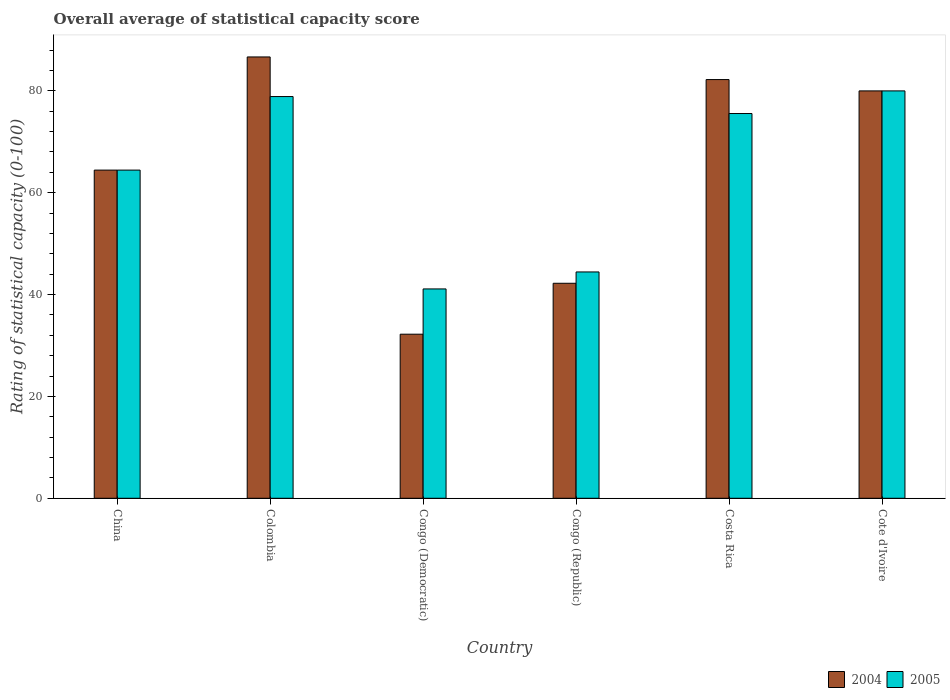How many different coloured bars are there?
Your response must be concise. 2. How many groups of bars are there?
Offer a very short reply. 6. Are the number of bars per tick equal to the number of legend labels?
Provide a succinct answer. Yes. How many bars are there on the 3rd tick from the right?
Provide a short and direct response. 2. In how many cases, is the number of bars for a given country not equal to the number of legend labels?
Offer a very short reply. 0. What is the rating of statistical capacity in 2005 in Costa Rica?
Your answer should be compact. 75.56. Across all countries, what is the maximum rating of statistical capacity in 2005?
Offer a very short reply. 80. Across all countries, what is the minimum rating of statistical capacity in 2004?
Your answer should be compact. 32.22. In which country was the rating of statistical capacity in 2005 maximum?
Give a very brief answer. Cote d'Ivoire. In which country was the rating of statistical capacity in 2005 minimum?
Offer a very short reply. Congo (Democratic). What is the total rating of statistical capacity in 2005 in the graph?
Offer a terse response. 384.44. What is the difference between the rating of statistical capacity in 2004 in Congo (Democratic) and that in Cote d'Ivoire?
Make the answer very short. -47.78. What is the difference between the rating of statistical capacity in 2005 in Congo (Democratic) and the rating of statistical capacity in 2004 in Cote d'Ivoire?
Offer a terse response. -38.89. What is the average rating of statistical capacity in 2005 per country?
Offer a very short reply. 64.07. What is the difference between the rating of statistical capacity of/in 2005 and rating of statistical capacity of/in 2004 in Congo (Democratic)?
Keep it short and to the point. 8.89. In how many countries, is the rating of statistical capacity in 2004 greater than 44?
Provide a short and direct response. 4. What is the ratio of the rating of statistical capacity in 2004 in Colombia to that in Congo (Republic)?
Your answer should be very brief. 2.05. Is the rating of statistical capacity in 2004 in China less than that in Costa Rica?
Ensure brevity in your answer.  Yes. What is the difference between the highest and the second highest rating of statistical capacity in 2004?
Ensure brevity in your answer.  -2.22. What is the difference between the highest and the lowest rating of statistical capacity in 2005?
Keep it short and to the point. 38.89. Is the sum of the rating of statistical capacity in 2004 in Congo (Democratic) and Congo (Republic) greater than the maximum rating of statistical capacity in 2005 across all countries?
Your response must be concise. No. How many bars are there?
Provide a short and direct response. 12. How many countries are there in the graph?
Your answer should be very brief. 6. What is the difference between two consecutive major ticks on the Y-axis?
Offer a very short reply. 20. Are the values on the major ticks of Y-axis written in scientific E-notation?
Your answer should be very brief. No. Does the graph contain any zero values?
Provide a succinct answer. No. Where does the legend appear in the graph?
Provide a short and direct response. Bottom right. How many legend labels are there?
Your answer should be very brief. 2. What is the title of the graph?
Your response must be concise. Overall average of statistical capacity score. Does "1973" appear as one of the legend labels in the graph?
Your response must be concise. No. What is the label or title of the X-axis?
Make the answer very short. Country. What is the label or title of the Y-axis?
Provide a succinct answer. Rating of statistical capacity (0-100). What is the Rating of statistical capacity (0-100) in 2004 in China?
Ensure brevity in your answer.  64.44. What is the Rating of statistical capacity (0-100) in 2005 in China?
Provide a succinct answer. 64.44. What is the Rating of statistical capacity (0-100) of 2004 in Colombia?
Your answer should be very brief. 86.67. What is the Rating of statistical capacity (0-100) of 2005 in Colombia?
Make the answer very short. 78.89. What is the Rating of statistical capacity (0-100) in 2004 in Congo (Democratic)?
Provide a succinct answer. 32.22. What is the Rating of statistical capacity (0-100) of 2005 in Congo (Democratic)?
Your answer should be very brief. 41.11. What is the Rating of statistical capacity (0-100) of 2004 in Congo (Republic)?
Ensure brevity in your answer.  42.22. What is the Rating of statistical capacity (0-100) of 2005 in Congo (Republic)?
Offer a terse response. 44.44. What is the Rating of statistical capacity (0-100) in 2004 in Costa Rica?
Provide a succinct answer. 82.22. What is the Rating of statistical capacity (0-100) of 2005 in Costa Rica?
Provide a succinct answer. 75.56. What is the Rating of statistical capacity (0-100) in 2004 in Cote d'Ivoire?
Your answer should be compact. 80. What is the Rating of statistical capacity (0-100) of 2005 in Cote d'Ivoire?
Offer a very short reply. 80. Across all countries, what is the maximum Rating of statistical capacity (0-100) in 2004?
Give a very brief answer. 86.67. Across all countries, what is the minimum Rating of statistical capacity (0-100) in 2004?
Your answer should be very brief. 32.22. Across all countries, what is the minimum Rating of statistical capacity (0-100) of 2005?
Offer a very short reply. 41.11. What is the total Rating of statistical capacity (0-100) in 2004 in the graph?
Your answer should be very brief. 387.78. What is the total Rating of statistical capacity (0-100) in 2005 in the graph?
Offer a terse response. 384.44. What is the difference between the Rating of statistical capacity (0-100) in 2004 in China and that in Colombia?
Make the answer very short. -22.22. What is the difference between the Rating of statistical capacity (0-100) of 2005 in China and that in Colombia?
Your answer should be compact. -14.44. What is the difference between the Rating of statistical capacity (0-100) in 2004 in China and that in Congo (Democratic)?
Offer a terse response. 32.22. What is the difference between the Rating of statistical capacity (0-100) in 2005 in China and that in Congo (Democratic)?
Provide a succinct answer. 23.33. What is the difference between the Rating of statistical capacity (0-100) of 2004 in China and that in Congo (Republic)?
Provide a short and direct response. 22.22. What is the difference between the Rating of statistical capacity (0-100) in 2004 in China and that in Costa Rica?
Offer a very short reply. -17.78. What is the difference between the Rating of statistical capacity (0-100) in 2005 in China and that in Costa Rica?
Offer a very short reply. -11.11. What is the difference between the Rating of statistical capacity (0-100) in 2004 in China and that in Cote d'Ivoire?
Offer a terse response. -15.56. What is the difference between the Rating of statistical capacity (0-100) in 2005 in China and that in Cote d'Ivoire?
Your response must be concise. -15.56. What is the difference between the Rating of statistical capacity (0-100) of 2004 in Colombia and that in Congo (Democratic)?
Make the answer very short. 54.44. What is the difference between the Rating of statistical capacity (0-100) in 2005 in Colombia and that in Congo (Democratic)?
Your answer should be very brief. 37.78. What is the difference between the Rating of statistical capacity (0-100) of 2004 in Colombia and that in Congo (Republic)?
Offer a very short reply. 44.44. What is the difference between the Rating of statistical capacity (0-100) of 2005 in Colombia and that in Congo (Republic)?
Your answer should be very brief. 34.44. What is the difference between the Rating of statistical capacity (0-100) in 2004 in Colombia and that in Costa Rica?
Keep it short and to the point. 4.44. What is the difference between the Rating of statistical capacity (0-100) in 2004 in Colombia and that in Cote d'Ivoire?
Offer a terse response. 6.67. What is the difference between the Rating of statistical capacity (0-100) of 2005 in Colombia and that in Cote d'Ivoire?
Your response must be concise. -1.11. What is the difference between the Rating of statistical capacity (0-100) in 2004 in Congo (Democratic) and that in Congo (Republic)?
Ensure brevity in your answer.  -10. What is the difference between the Rating of statistical capacity (0-100) in 2004 in Congo (Democratic) and that in Costa Rica?
Offer a very short reply. -50. What is the difference between the Rating of statistical capacity (0-100) in 2005 in Congo (Democratic) and that in Costa Rica?
Offer a terse response. -34.44. What is the difference between the Rating of statistical capacity (0-100) of 2004 in Congo (Democratic) and that in Cote d'Ivoire?
Provide a succinct answer. -47.78. What is the difference between the Rating of statistical capacity (0-100) of 2005 in Congo (Democratic) and that in Cote d'Ivoire?
Your answer should be very brief. -38.89. What is the difference between the Rating of statistical capacity (0-100) of 2004 in Congo (Republic) and that in Costa Rica?
Your answer should be very brief. -40. What is the difference between the Rating of statistical capacity (0-100) in 2005 in Congo (Republic) and that in Costa Rica?
Make the answer very short. -31.11. What is the difference between the Rating of statistical capacity (0-100) of 2004 in Congo (Republic) and that in Cote d'Ivoire?
Provide a succinct answer. -37.78. What is the difference between the Rating of statistical capacity (0-100) of 2005 in Congo (Republic) and that in Cote d'Ivoire?
Offer a very short reply. -35.56. What is the difference between the Rating of statistical capacity (0-100) of 2004 in Costa Rica and that in Cote d'Ivoire?
Your response must be concise. 2.22. What is the difference between the Rating of statistical capacity (0-100) of 2005 in Costa Rica and that in Cote d'Ivoire?
Provide a succinct answer. -4.44. What is the difference between the Rating of statistical capacity (0-100) of 2004 in China and the Rating of statistical capacity (0-100) of 2005 in Colombia?
Give a very brief answer. -14.44. What is the difference between the Rating of statistical capacity (0-100) in 2004 in China and the Rating of statistical capacity (0-100) in 2005 in Congo (Democratic)?
Give a very brief answer. 23.33. What is the difference between the Rating of statistical capacity (0-100) of 2004 in China and the Rating of statistical capacity (0-100) of 2005 in Congo (Republic)?
Provide a short and direct response. 20. What is the difference between the Rating of statistical capacity (0-100) of 2004 in China and the Rating of statistical capacity (0-100) of 2005 in Costa Rica?
Offer a terse response. -11.11. What is the difference between the Rating of statistical capacity (0-100) of 2004 in China and the Rating of statistical capacity (0-100) of 2005 in Cote d'Ivoire?
Provide a short and direct response. -15.56. What is the difference between the Rating of statistical capacity (0-100) of 2004 in Colombia and the Rating of statistical capacity (0-100) of 2005 in Congo (Democratic)?
Keep it short and to the point. 45.56. What is the difference between the Rating of statistical capacity (0-100) of 2004 in Colombia and the Rating of statistical capacity (0-100) of 2005 in Congo (Republic)?
Give a very brief answer. 42.22. What is the difference between the Rating of statistical capacity (0-100) in 2004 in Colombia and the Rating of statistical capacity (0-100) in 2005 in Costa Rica?
Give a very brief answer. 11.11. What is the difference between the Rating of statistical capacity (0-100) in 2004 in Colombia and the Rating of statistical capacity (0-100) in 2005 in Cote d'Ivoire?
Provide a short and direct response. 6.67. What is the difference between the Rating of statistical capacity (0-100) of 2004 in Congo (Democratic) and the Rating of statistical capacity (0-100) of 2005 in Congo (Republic)?
Offer a terse response. -12.22. What is the difference between the Rating of statistical capacity (0-100) in 2004 in Congo (Democratic) and the Rating of statistical capacity (0-100) in 2005 in Costa Rica?
Offer a very short reply. -43.33. What is the difference between the Rating of statistical capacity (0-100) of 2004 in Congo (Democratic) and the Rating of statistical capacity (0-100) of 2005 in Cote d'Ivoire?
Make the answer very short. -47.78. What is the difference between the Rating of statistical capacity (0-100) of 2004 in Congo (Republic) and the Rating of statistical capacity (0-100) of 2005 in Costa Rica?
Keep it short and to the point. -33.33. What is the difference between the Rating of statistical capacity (0-100) of 2004 in Congo (Republic) and the Rating of statistical capacity (0-100) of 2005 in Cote d'Ivoire?
Keep it short and to the point. -37.78. What is the difference between the Rating of statistical capacity (0-100) in 2004 in Costa Rica and the Rating of statistical capacity (0-100) in 2005 in Cote d'Ivoire?
Your response must be concise. 2.22. What is the average Rating of statistical capacity (0-100) in 2004 per country?
Ensure brevity in your answer.  64.63. What is the average Rating of statistical capacity (0-100) of 2005 per country?
Your answer should be very brief. 64.07. What is the difference between the Rating of statistical capacity (0-100) in 2004 and Rating of statistical capacity (0-100) in 2005 in China?
Make the answer very short. 0. What is the difference between the Rating of statistical capacity (0-100) of 2004 and Rating of statistical capacity (0-100) of 2005 in Colombia?
Give a very brief answer. 7.78. What is the difference between the Rating of statistical capacity (0-100) of 2004 and Rating of statistical capacity (0-100) of 2005 in Congo (Democratic)?
Your answer should be compact. -8.89. What is the difference between the Rating of statistical capacity (0-100) in 2004 and Rating of statistical capacity (0-100) in 2005 in Congo (Republic)?
Your response must be concise. -2.22. What is the ratio of the Rating of statistical capacity (0-100) in 2004 in China to that in Colombia?
Offer a terse response. 0.74. What is the ratio of the Rating of statistical capacity (0-100) of 2005 in China to that in Colombia?
Provide a succinct answer. 0.82. What is the ratio of the Rating of statistical capacity (0-100) in 2004 in China to that in Congo (Democratic)?
Provide a short and direct response. 2. What is the ratio of the Rating of statistical capacity (0-100) of 2005 in China to that in Congo (Democratic)?
Your answer should be compact. 1.57. What is the ratio of the Rating of statistical capacity (0-100) in 2004 in China to that in Congo (Republic)?
Your answer should be compact. 1.53. What is the ratio of the Rating of statistical capacity (0-100) in 2005 in China to that in Congo (Republic)?
Your response must be concise. 1.45. What is the ratio of the Rating of statistical capacity (0-100) of 2004 in China to that in Costa Rica?
Provide a short and direct response. 0.78. What is the ratio of the Rating of statistical capacity (0-100) of 2005 in China to that in Costa Rica?
Your response must be concise. 0.85. What is the ratio of the Rating of statistical capacity (0-100) of 2004 in China to that in Cote d'Ivoire?
Keep it short and to the point. 0.81. What is the ratio of the Rating of statistical capacity (0-100) in 2005 in China to that in Cote d'Ivoire?
Make the answer very short. 0.81. What is the ratio of the Rating of statistical capacity (0-100) in 2004 in Colombia to that in Congo (Democratic)?
Provide a succinct answer. 2.69. What is the ratio of the Rating of statistical capacity (0-100) in 2005 in Colombia to that in Congo (Democratic)?
Your answer should be very brief. 1.92. What is the ratio of the Rating of statistical capacity (0-100) of 2004 in Colombia to that in Congo (Republic)?
Your answer should be compact. 2.05. What is the ratio of the Rating of statistical capacity (0-100) of 2005 in Colombia to that in Congo (Republic)?
Offer a very short reply. 1.77. What is the ratio of the Rating of statistical capacity (0-100) of 2004 in Colombia to that in Costa Rica?
Your answer should be compact. 1.05. What is the ratio of the Rating of statistical capacity (0-100) in 2005 in Colombia to that in Costa Rica?
Offer a terse response. 1.04. What is the ratio of the Rating of statistical capacity (0-100) in 2004 in Colombia to that in Cote d'Ivoire?
Give a very brief answer. 1.08. What is the ratio of the Rating of statistical capacity (0-100) in 2005 in Colombia to that in Cote d'Ivoire?
Provide a succinct answer. 0.99. What is the ratio of the Rating of statistical capacity (0-100) in 2004 in Congo (Democratic) to that in Congo (Republic)?
Keep it short and to the point. 0.76. What is the ratio of the Rating of statistical capacity (0-100) of 2005 in Congo (Democratic) to that in Congo (Republic)?
Your answer should be very brief. 0.93. What is the ratio of the Rating of statistical capacity (0-100) in 2004 in Congo (Democratic) to that in Costa Rica?
Provide a short and direct response. 0.39. What is the ratio of the Rating of statistical capacity (0-100) in 2005 in Congo (Democratic) to that in Costa Rica?
Make the answer very short. 0.54. What is the ratio of the Rating of statistical capacity (0-100) of 2004 in Congo (Democratic) to that in Cote d'Ivoire?
Make the answer very short. 0.4. What is the ratio of the Rating of statistical capacity (0-100) in 2005 in Congo (Democratic) to that in Cote d'Ivoire?
Give a very brief answer. 0.51. What is the ratio of the Rating of statistical capacity (0-100) of 2004 in Congo (Republic) to that in Costa Rica?
Give a very brief answer. 0.51. What is the ratio of the Rating of statistical capacity (0-100) of 2005 in Congo (Republic) to that in Costa Rica?
Offer a very short reply. 0.59. What is the ratio of the Rating of statistical capacity (0-100) of 2004 in Congo (Republic) to that in Cote d'Ivoire?
Keep it short and to the point. 0.53. What is the ratio of the Rating of statistical capacity (0-100) of 2005 in Congo (Republic) to that in Cote d'Ivoire?
Provide a succinct answer. 0.56. What is the ratio of the Rating of statistical capacity (0-100) of 2004 in Costa Rica to that in Cote d'Ivoire?
Offer a terse response. 1.03. What is the difference between the highest and the second highest Rating of statistical capacity (0-100) of 2004?
Provide a succinct answer. 4.44. What is the difference between the highest and the lowest Rating of statistical capacity (0-100) in 2004?
Your answer should be very brief. 54.44. What is the difference between the highest and the lowest Rating of statistical capacity (0-100) in 2005?
Provide a succinct answer. 38.89. 